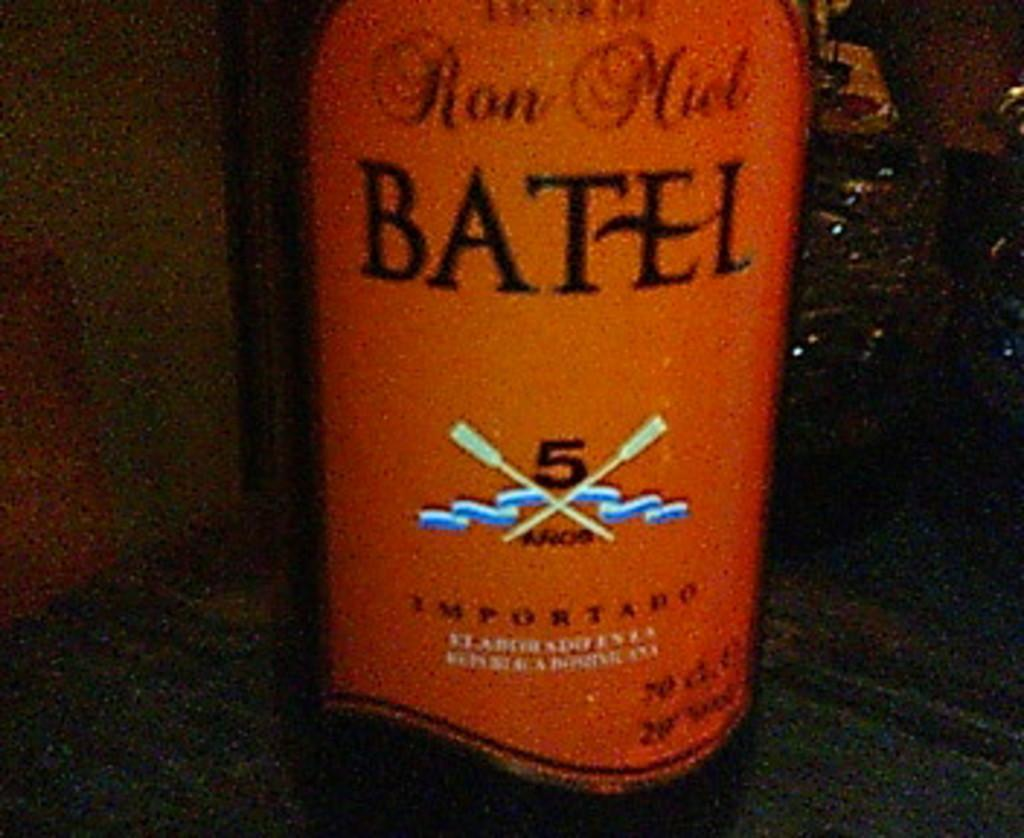<image>
Summarize the visual content of the image. An orange bottle of  Ron Miel Batel 5. 